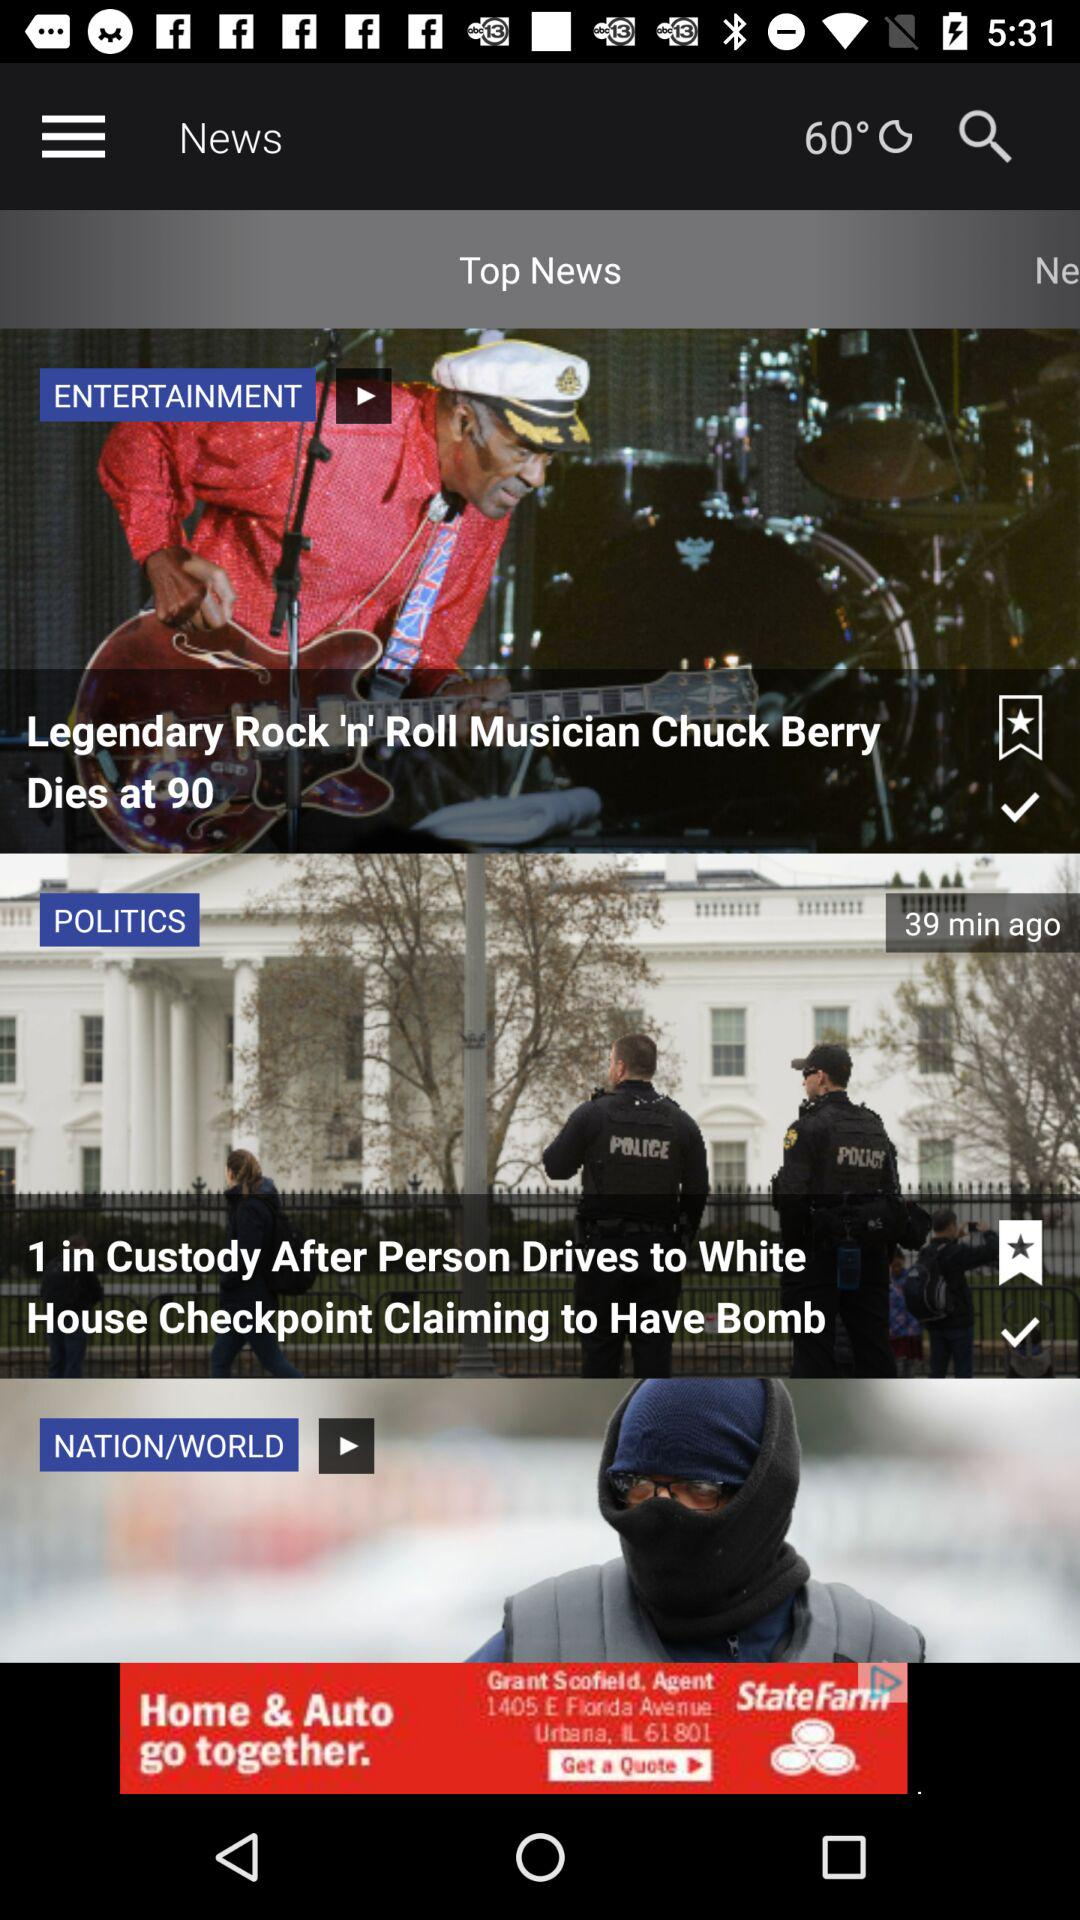Which news has been saved as a bookmark? The news that has been saved as a bookmark is "1 in Custody After Person Drives to White House Checkpoint Claiming to Have Bomb". 